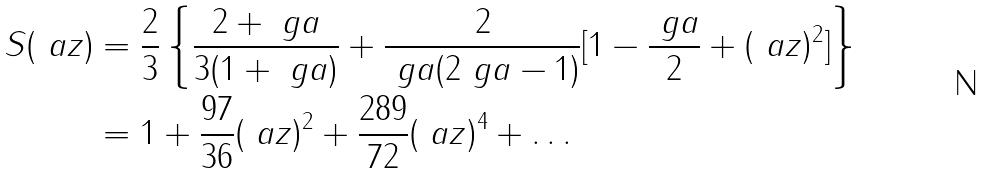<formula> <loc_0><loc_0><loc_500><loc_500>S ( \ a z ) & = \frac { 2 } { 3 } \left \{ \frac { 2 + \ g a } { 3 ( 1 + \ g a ) } + \frac { 2 } { \ g a ( 2 \ g a - 1 ) } [ 1 - \frac { \ g a } { 2 } + ( \ a z ) ^ { 2 } ] \right \} \\ & = 1 + \frac { 9 7 } { 3 6 } ( \ a z ) ^ { 2 } + \frac { 2 8 9 } { 7 2 } ( \ a z ) ^ { 4 } + \dots \,</formula> 